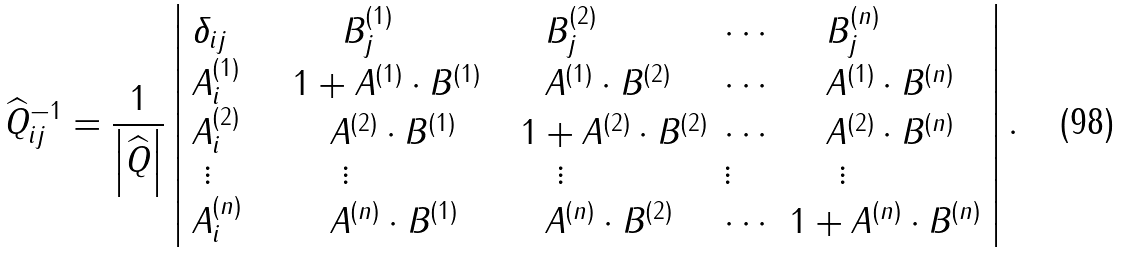Convert formula to latex. <formula><loc_0><loc_0><loc_500><loc_500>\widehat { Q } _ { i j } ^ { - 1 } = \frac { 1 } { \left | \widehat { Q } \right | } \left | \begin{array} { l l l l l } \delta _ { i j } \quad & \ \quad B _ { j } ^ { ( 1 ) } & \quad B _ { j } ^ { ( 2 ) } & \cdots & \quad B _ { j } ^ { ( n ) } \\ A _ { i } ^ { ( 1 ) } \quad & 1 + { A } ^ { ( 1 ) } \cdot { B } ^ { ( 1 ) } & \quad { A } ^ { ( 1 ) } \cdot { B } ^ { ( 2 ) } & \cdots & \quad { A } ^ { ( 1 ) } \cdot { B } ^ { ( n ) } \\ A _ { i } ^ { ( 2 ) } & \quad { A } ^ { ( 2 ) } \cdot { B } ^ { ( 1 ) } { \quad } & \ 1 + { A } ^ { ( 2 ) } \cdot { B } ^ { ( 2 ) } & \cdots & \quad { A } ^ { ( 2 ) } \cdot { B } ^ { ( n ) } \\ \ \vdots & \ \quad \vdots & \ \quad \vdots & \vdots & \ \quad \vdots \\ A _ { i } ^ { ( n ) } & \quad { A } ^ { ( n ) } \cdot { B } ^ { ( 1 ) } & \quad { A } ^ { ( n ) } \cdot { B } ^ { ( 2 ) } & \cdots & 1 + { A } ^ { ( n ) } \cdot { B } ^ { ( n ) } \end{array} \right | .</formula> 